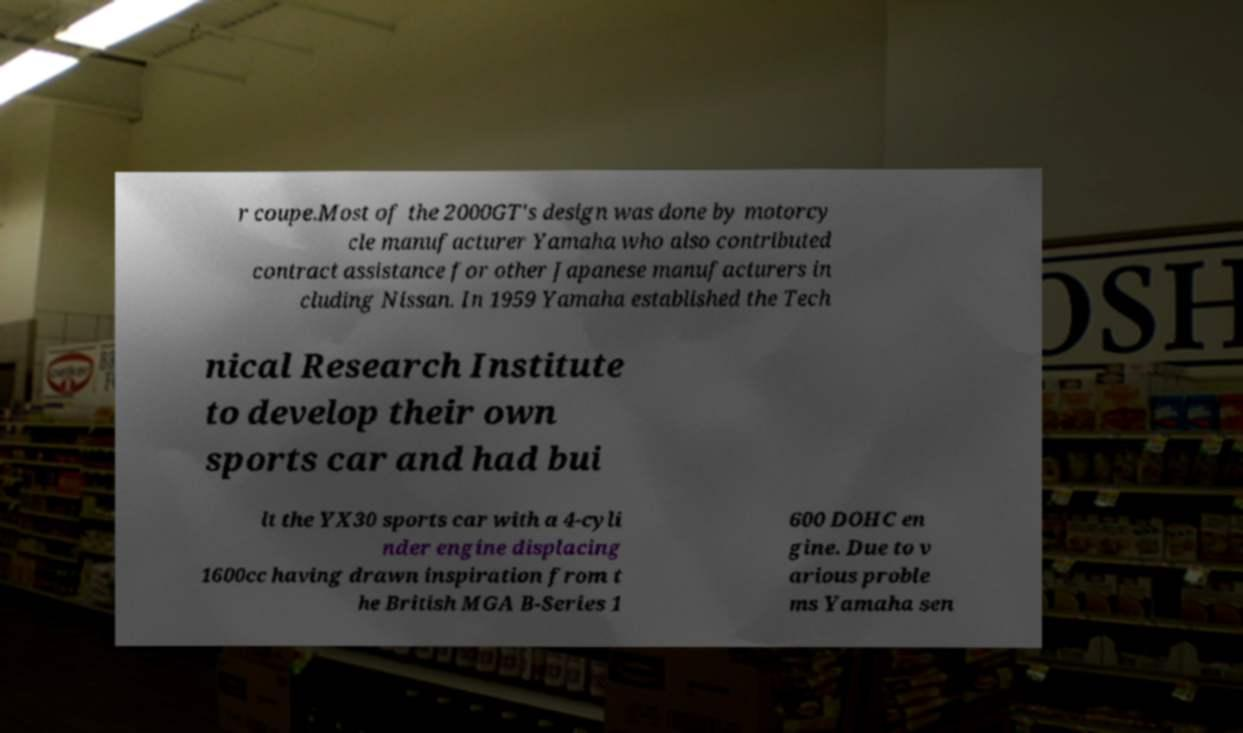Please read and relay the text visible in this image. What does it say? r coupe.Most of the 2000GT's design was done by motorcy cle manufacturer Yamaha who also contributed contract assistance for other Japanese manufacturers in cluding Nissan. In 1959 Yamaha established the Tech nical Research Institute to develop their own sports car and had bui lt the YX30 sports car with a 4-cyli nder engine displacing 1600cc having drawn inspiration from t he British MGA B-Series 1 600 DOHC en gine. Due to v arious proble ms Yamaha sen 